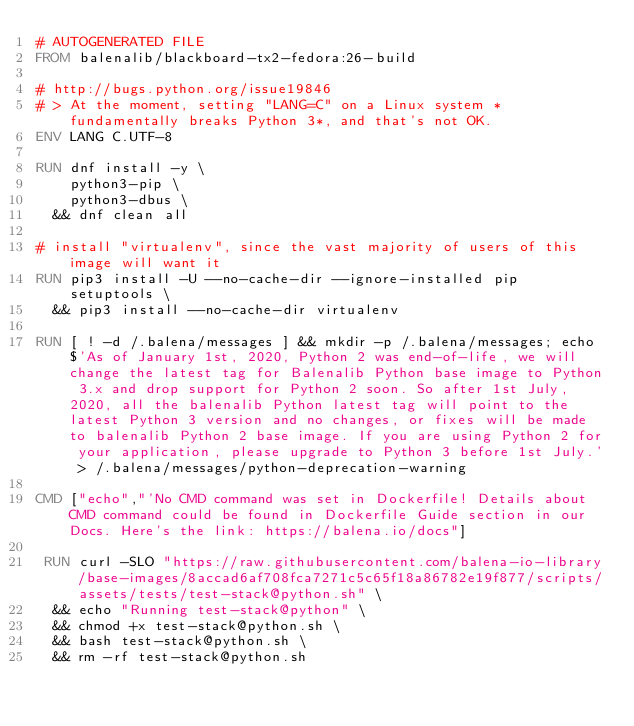<code> <loc_0><loc_0><loc_500><loc_500><_Dockerfile_># AUTOGENERATED FILE
FROM balenalib/blackboard-tx2-fedora:26-build

# http://bugs.python.org/issue19846
# > At the moment, setting "LANG=C" on a Linux system *fundamentally breaks Python 3*, and that's not OK.
ENV LANG C.UTF-8

RUN dnf install -y \
		python3-pip \
		python3-dbus \
	&& dnf clean all

# install "virtualenv", since the vast majority of users of this image will want it
RUN pip3 install -U --no-cache-dir --ignore-installed pip setuptools \
	&& pip3 install --no-cache-dir virtualenv

RUN [ ! -d /.balena/messages ] && mkdir -p /.balena/messages; echo $'As of January 1st, 2020, Python 2 was end-of-life, we will change the latest tag for Balenalib Python base image to Python 3.x and drop support for Python 2 soon. So after 1st July, 2020, all the balenalib Python latest tag will point to the latest Python 3 version and no changes, or fixes will be made to balenalib Python 2 base image. If you are using Python 2 for your application, please upgrade to Python 3 before 1st July.' > /.balena/messages/python-deprecation-warning

CMD ["echo","'No CMD command was set in Dockerfile! Details about CMD command could be found in Dockerfile Guide section in our Docs. Here's the link: https://balena.io/docs"]

 RUN curl -SLO "https://raw.githubusercontent.com/balena-io-library/base-images/8accad6af708fca7271c5c65f18a86782e19f877/scripts/assets/tests/test-stack@python.sh" \
  && echo "Running test-stack@python" \
  && chmod +x test-stack@python.sh \
  && bash test-stack@python.sh \
  && rm -rf test-stack@python.sh 
</code> 